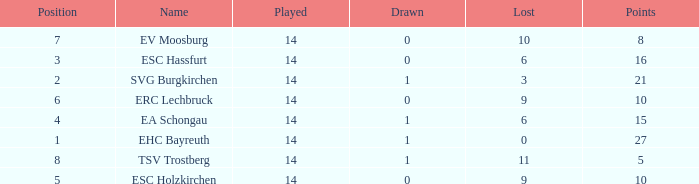What's the points that has a lost more 6, played less than 14 and a position more than 1? None. 